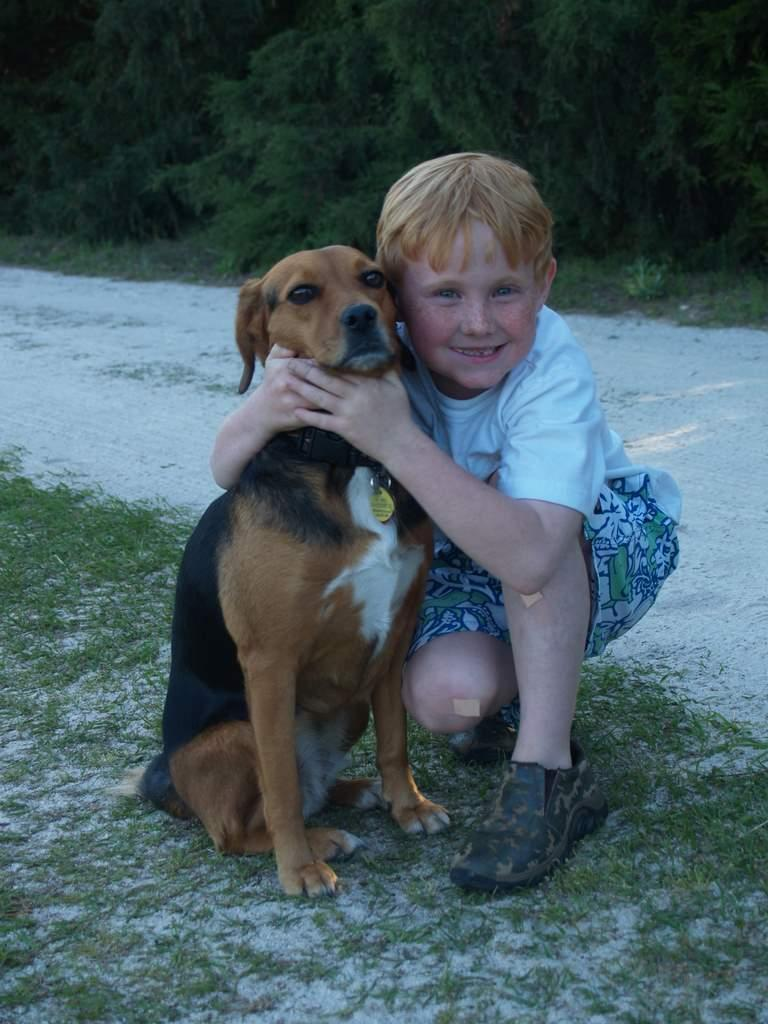What is located in the center of the image? There is a boy and a dog in the center of the image. What can be seen in the background of the image? There are trees in the background of the image. What type of vegetation is at the bottom of the image? There is grass at the bottom of the image. What type of shoe is the bee wearing in the image? There is no bee present in the image, and therefore no shoes or any bee-related information can be observed. 